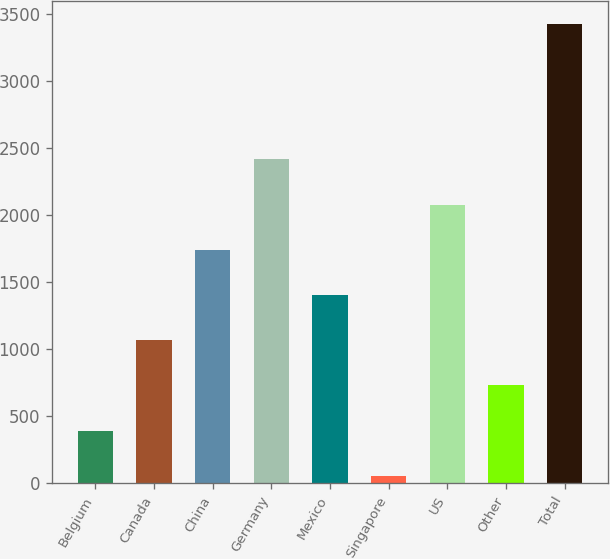Convert chart to OTSL. <chart><loc_0><loc_0><loc_500><loc_500><bar_chart><fcel>Belgium<fcel>Canada<fcel>China<fcel>Germany<fcel>Mexico<fcel>Singapore<fcel>US<fcel>Other<fcel>Total<nl><fcel>390.2<fcel>1064.6<fcel>1739<fcel>2413.4<fcel>1401.8<fcel>53<fcel>2076.2<fcel>727.4<fcel>3425<nl></chart> 